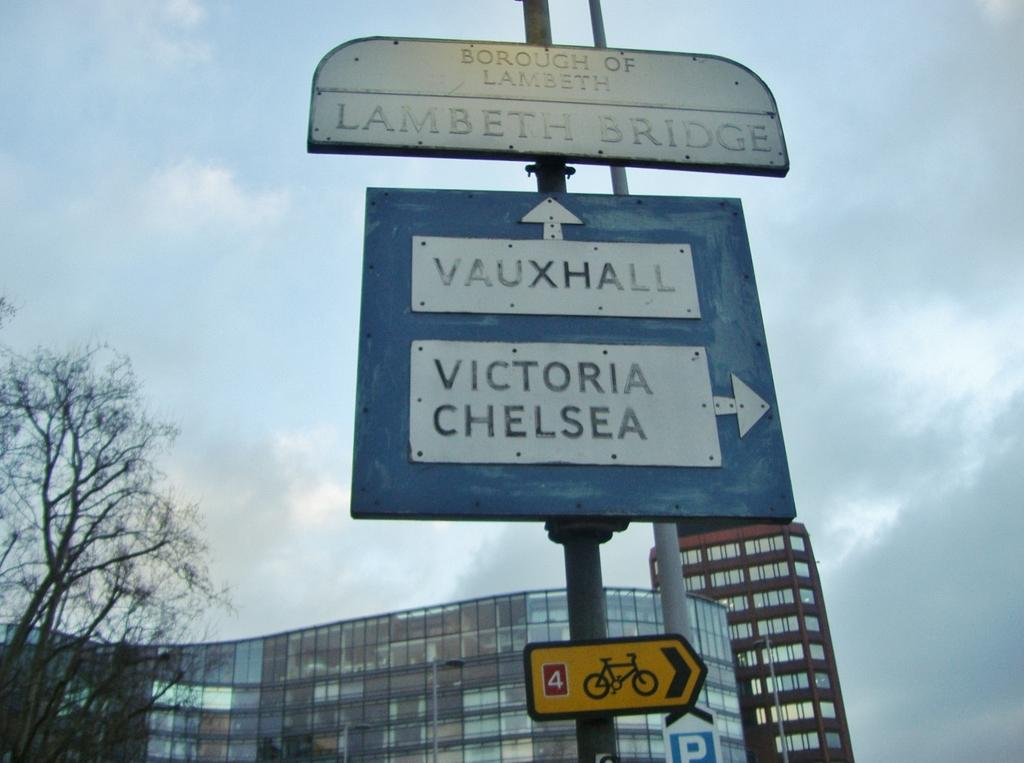<image>
Relay a brief, clear account of the picture shown. A direction sign titled Lambeth Bridge with Vauxhall straight ahead and Victoria Chelsea to the right. 